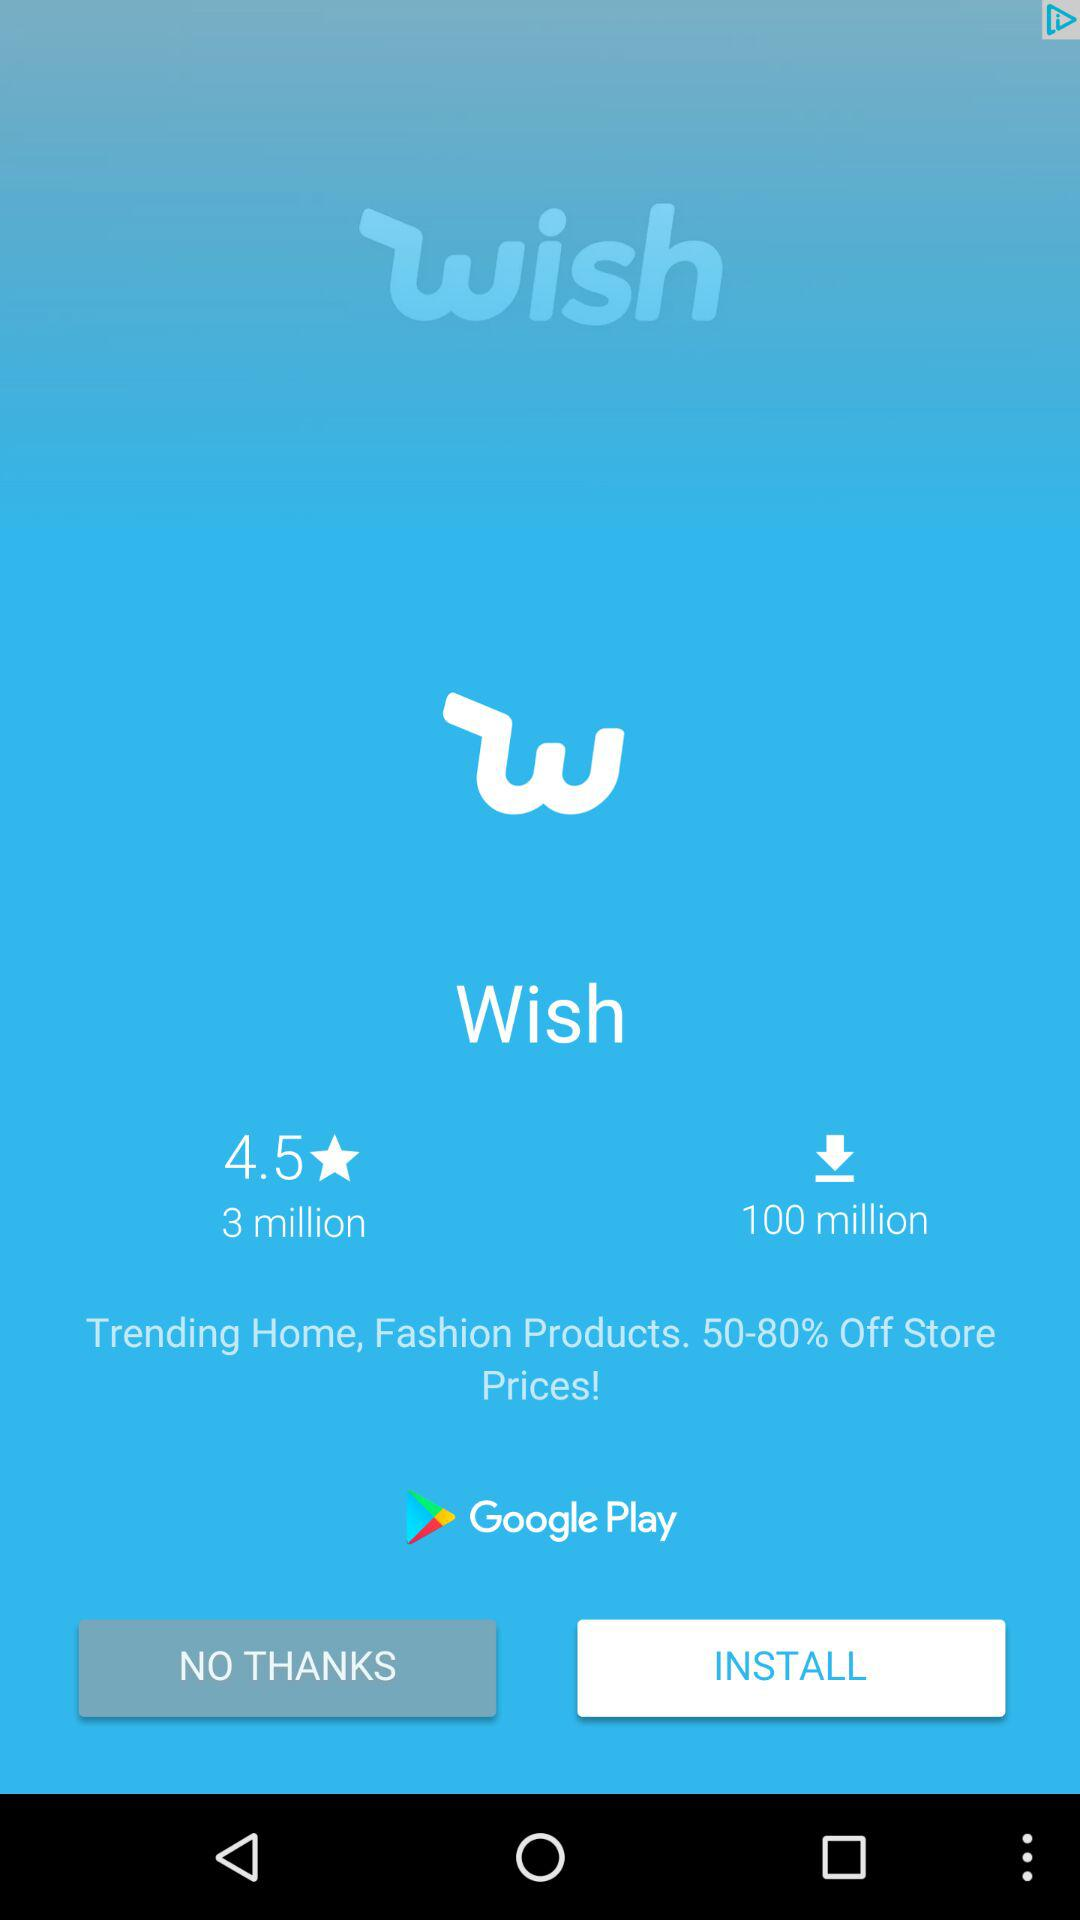How many more downloads does Wish have than reviews?
Answer the question using a single word or phrase. 97 million 